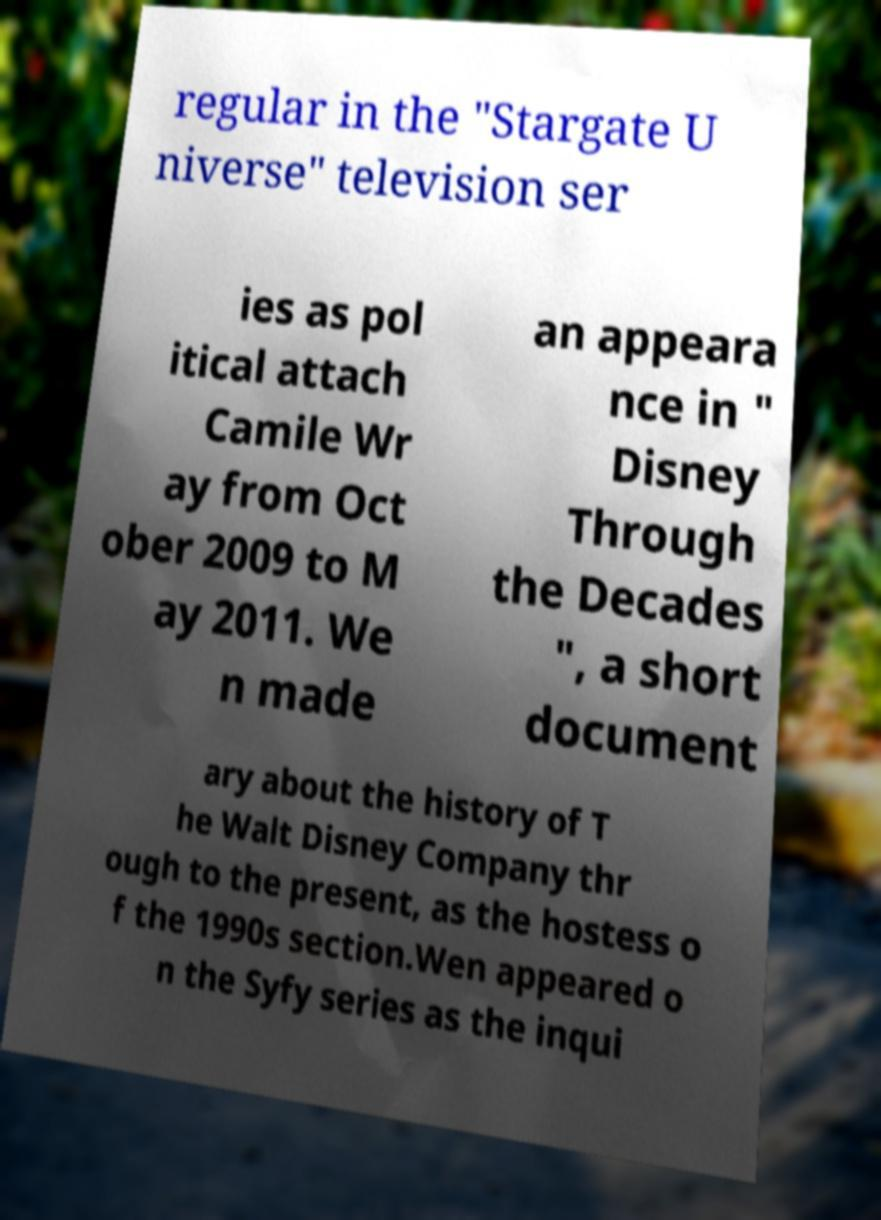What messages or text are displayed in this image? I need them in a readable, typed format. regular in the "Stargate U niverse" television ser ies as pol itical attach Camile Wr ay from Oct ober 2009 to M ay 2011. We n made an appeara nce in " Disney Through the Decades ", a short document ary about the history of T he Walt Disney Company thr ough to the present, as the hostess o f the 1990s section.Wen appeared o n the Syfy series as the inqui 